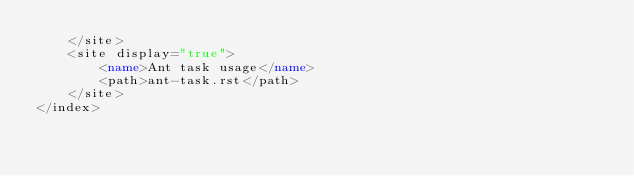<code> <loc_0><loc_0><loc_500><loc_500><_XML_>    </site>
    <site display="true">
        <name>Ant task usage</name>
        <path>ant-task.rst</path>
    </site>
</index>

</code> 